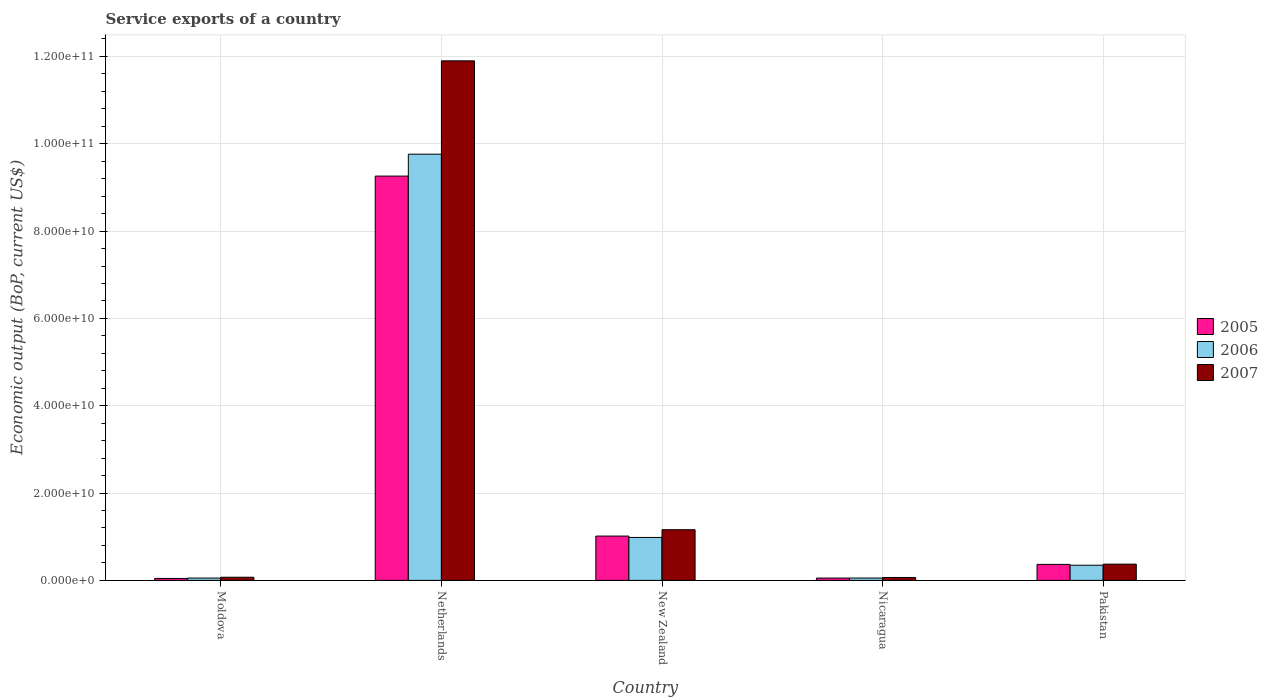How many groups of bars are there?
Offer a very short reply. 5. Are the number of bars per tick equal to the number of legend labels?
Offer a very short reply. Yes. How many bars are there on the 5th tick from the left?
Offer a terse response. 3. How many bars are there on the 2nd tick from the right?
Your answer should be very brief. 3. What is the label of the 1st group of bars from the left?
Make the answer very short. Moldova. What is the service exports in 2005 in Pakistan?
Your answer should be compact. 3.66e+09. Across all countries, what is the maximum service exports in 2006?
Your answer should be very brief. 9.76e+1. Across all countries, what is the minimum service exports in 2007?
Keep it short and to the point. 6.66e+08. In which country was the service exports in 2005 maximum?
Your answer should be very brief. Netherlands. In which country was the service exports in 2007 minimum?
Give a very brief answer. Nicaragua. What is the total service exports in 2007 in the graph?
Your answer should be very brief. 1.36e+11. What is the difference between the service exports in 2007 in Moldova and that in Netherlands?
Your answer should be compact. -1.18e+11. What is the difference between the service exports in 2006 in Nicaragua and the service exports in 2005 in Moldova?
Your answer should be very brief. 9.26e+07. What is the average service exports in 2006 per country?
Provide a short and direct response. 2.24e+1. What is the difference between the service exports of/in 2005 and service exports of/in 2006 in Pakistan?
Offer a very short reply. 1.89e+08. What is the ratio of the service exports in 2007 in Netherlands to that in Nicaragua?
Offer a terse response. 178.76. Is the service exports in 2006 in Netherlands less than that in New Zealand?
Give a very brief answer. No. Is the difference between the service exports in 2005 in New Zealand and Nicaragua greater than the difference between the service exports in 2006 in New Zealand and Nicaragua?
Your answer should be very brief. Yes. What is the difference between the highest and the second highest service exports in 2006?
Offer a very short reply. -6.36e+09. What is the difference between the highest and the lowest service exports in 2007?
Provide a succinct answer. 1.18e+11. Is it the case that in every country, the sum of the service exports in 2006 and service exports in 2005 is greater than the service exports in 2007?
Make the answer very short. Yes. How many countries are there in the graph?
Your response must be concise. 5. Are the values on the major ticks of Y-axis written in scientific E-notation?
Ensure brevity in your answer.  Yes. Does the graph contain any zero values?
Offer a terse response. No. Where does the legend appear in the graph?
Give a very brief answer. Center right. How many legend labels are there?
Your answer should be compact. 3. How are the legend labels stacked?
Give a very brief answer. Vertical. What is the title of the graph?
Your response must be concise. Service exports of a country. Does "1994" appear as one of the legend labels in the graph?
Make the answer very short. No. What is the label or title of the Y-axis?
Make the answer very short. Economic output (BoP, current US$). What is the Economic output (BoP, current US$) of 2005 in Moldova?
Give a very brief answer. 4.46e+08. What is the Economic output (BoP, current US$) of 2006 in Moldova?
Offer a terse response. 5.35e+08. What is the Economic output (BoP, current US$) of 2007 in Moldova?
Make the answer very short. 7.19e+08. What is the Economic output (BoP, current US$) of 2005 in Netherlands?
Give a very brief answer. 9.26e+1. What is the Economic output (BoP, current US$) in 2006 in Netherlands?
Offer a terse response. 9.76e+1. What is the Economic output (BoP, current US$) of 2007 in Netherlands?
Give a very brief answer. 1.19e+11. What is the Economic output (BoP, current US$) of 2005 in New Zealand?
Offer a very short reply. 1.02e+1. What is the Economic output (BoP, current US$) of 2006 in New Zealand?
Give a very brief answer. 9.84e+09. What is the Economic output (BoP, current US$) in 2007 in New Zealand?
Offer a terse response. 1.16e+1. What is the Economic output (BoP, current US$) of 2005 in Nicaragua?
Provide a short and direct response. 5.31e+08. What is the Economic output (BoP, current US$) in 2006 in Nicaragua?
Provide a short and direct response. 5.39e+08. What is the Economic output (BoP, current US$) of 2007 in Nicaragua?
Your response must be concise. 6.66e+08. What is the Economic output (BoP, current US$) of 2005 in Pakistan?
Offer a terse response. 3.66e+09. What is the Economic output (BoP, current US$) of 2006 in Pakistan?
Provide a succinct answer. 3.48e+09. What is the Economic output (BoP, current US$) in 2007 in Pakistan?
Your answer should be compact. 3.72e+09. Across all countries, what is the maximum Economic output (BoP, current US$) of 2005?
Your answer should be compact. 9.26e+1. Across all countries, what is the maximum Economic output (BoP, current US$) in 2006?
Offer a very short reply. 9.76e+1. Across all countries, what is the maximum Economic output (BoP, current US$) in 2007?
Ensure brevity in your answer.  1.19e+11. Across all countries, what is the minimum Economic output (BoP, current US$) of 2005?
Give a very brief answer. 4.46e+08. Across all countries, what is the minimum Economic output (BoP, current US$) in 2006?
Your response must be concise. 5.35e+08. Across all countries, what is the minimum Economic output (BoP, current US$) in 2007?
Your answer should be compact. 6.66e+08. What is the total Economic output (BoP, current US$) in 2005 in the graph?
Your answer should be compact. 1.07e+11. What is the total Economic output (BoP, current US$) in 2006 in the graph?
Ensure brevity in your answer.  1.12e+11. What is the total Economic output (BoP, current US$) in 2007 in the graph?
Keep it short and to the point. 1.36e+11. What is the difference between the Economic output (BoP, current US$) of 2005 in Moldova and that in Netherlands?
Make the answer very short. -9.21e+1. What is the difference between the Economic output (BoP, current US$) of 2006 in Moldova and that in Netherlands?
Offer a very short reply. -9.71e+1. What is the difference between the Economic output (BoP, current US$) of 2007 in Moldova and that in Netherlands?
Keep it short and to the point. -1.18e+11. What is the difference between the Economic output (BoP, current US$) of 2005 in Moldova and that in New Zealand?
Make the answer very short. -9.71e+09. What is the difference between the Economic output (BoP, current US$) in 2006 in Moldova and that in New Zealand?
Your answer should be very brief. -9.30e+09. What is the difference between the Economic output (BoP, current US$) in 2007 in Moldova and that in New Zealand?
Your answer should be very brief. -1.09e+1. What is the difference between the Economic output (BoP, current US$) of 2005 in Moldova and that in Nicaragua?
Your answer should be very brief. -8.46e+07. What is the difference between the Economic output (BoP, current US$) of 2006 in Moldova and that in Nicaragua?
Give a very brief answer. -3.60e+06. What is the difference between the Economic output (BoP, current US$) in 2007 in Moldova and that in Nicaragua?
Provide a short and direct response. 5.38e+07. What is the difference between the Economic output (BoP, current US$) in 2005 in Moldova and that in Pakistan?
Provide a short and direct response. -3.22e+09. What is the difference between the Economic output (BoP, current US$) in 2006 in Moldova and that in Pakistan?
Your response must be concise. -2.94e+09. What is the difference between the Economic output (BoP, current US$) of 2007 in Moldova and that in Pakistan?
Your answer should be compact. -3.00e+09. What is the difference between the Economic output (BoP, current US$) in 2005 in Netherlands and that in New Zealand?
Make the answer very short. 8.24e+1. What is the difference between the Economic output (BoP, current US$) of 2006 in Netherlands and that in New Zealand?
Provide a short and direct response. 8.78e+1. What is the difference between the Economic output (BoP, current US$) of 2007 in Netherlands and that in New Zealand?
Provide a succinct answer. 1.07e+11. What is the difference between the Economic output (BoP, current US$) of 2005 in Netherlands and that in Nicaragua?
Offer a terse response. 9.21e+1. What is the difference between the Economic output (BoP, current US$) in 2006 in Netherlands and that in Nicaragua?
Ensure brevity in your answer.  9.71e+1. What is the difference between the Economic output (BoP, current US$) of 2007 in Netherlands and that in Nicaragua?
Ensure brevity in your answer.  1.18e+11. What is the difference between the Economic output (BoP, current US$) of 2005 in Netherlands and that in Pakistan?
Your answer should be very brief. 8.89e+1. What is the difference between the Economic output (BoP, current US$) in 2006 in Netherlands and that in Pakistan?
Offer a very short reply. 9.41e+1. What is the difference between the Economic output (BoP, current US$) in 2007 in Netherlands and that in Pakistan?
Offer a very short reply. 1.15e+11. What is the difference between the Economic output (BoP, current US$) of 2005 in New Zealand and that in Nicaragua?
Your response must be concise. 9.62e+09. What is the difference between the Economic output (BoP, current US$) in 2006 in New Zealand and that in Nicaragua?
Ensure brevity in your answer.  9.30e+09. What is the difference between the Economic output (BoP, current US$) of 2007 in New Zealand and that in Nicaragua?
Your response must be concise. 1.09e+1. What is the difference between the Economic output (BoP, current US$) of 2005 in New Zealand and that in Pakistan?
Keep it short and to the point. 6.49e+09. What is the difference between the Economic output (BoP, current US$) in 2006 in New Zealand and that in Pakistan?
Provide a short and direct response. 6.36e+09. What is the difference between the Economic output (BoP, current US$) of 2007 in New Zealand and that in Pakistan?
Provide a succinct answer. 7.88e+09. What is the difference between the Economic output (BoP, current US$) of 2005 in Nicaragua and that in Pakistan?
Your answer should be very brief. -3.13e+09. What is the difference between the Economic output (BoP, current US$) of 2006 in Nicaragua and that in Pakistan?
Keep it short and to the point. -2.94e+09. What is the difference between the Economic output (BoP, current US$) in 2007 in Nicaragua and that in Pakistan?
Offer a terse response. -3.06e+09. What is the difference between the Economic output (BoP, current US$) of 2005 in Moldova and the Economic output (BoP, current US$) of 2006 in Netherlands?
Ensure brevity in your answer.  -9.72e+1. What is the difference between the Economic output (BoP, current US$) in 2005 in Moldova and the Economic output (BoP, current US$) in 2007 in Netherlands?
Offer a very short reply. -1.19e+11. What is the difference between the Economic output (BoP, current US$) of 2006 in Moldova and the Economic output (BoP, current US$) of 2007 in Netherlands?
Make the answer very short. -1.18e+11. What is the difference between the Economic output (BoP, current US$) in 2005 in Moldova and the Economic output (BoP, current US$) in 2006 in New Zealand?
Ensure brevity in your answer.  -9.39e+09. What is the difference between the Economic output (BoP, current US$) in 2005 in Moldova and the Economic output (BoP, current US$) in 2007 in New Zealand?
Your answer should be compact. -1.12e+1. What is the difference between the Economic output (BoP, current US$) in 2006 in Moldova and the Economic output (BoP, current US$) in 2007 in New Zealand?
Provide a succinct answer. -1.11e+1. What is the difference between the Economic output (BoP, current US$) in 2005 in Moldova and the Economic output (BoP, current US$) in 2006 in Nicaragua?
Make the answer very short. -9.26e+07. What is the difference between the Economic output (BoP, current US$) of 2005 in Moldova and the Economic output (BoP, current US$) of 2007 in Nicaragua?
Provide a succinct answer. -2.19e+08. What is the difference between the Economic output (BoP, current US$) in 2006 in Moldova and the Economic output (BoP, current US$) in 2007 in Nicaragua?
Your answer should be very brief. -1.30e+08. What is the difference between the Economic output (BoP, current US$) of 2005 in Moldova and the Economic output (BoP, current US$) of 2006 in Pakistan?
Ensure brevity in your answer.  -3.03e+09. What is the difference between the Economic output (BoP, current US$) in 2005 in Moldova and the Economic output (BoP, current US$) in 2007 in Pakistan?
Offer a very short reply. -3.27e+09. What is the difference between the Economic output (BoP, current US$) of 2006 in Moldova and the Economic output (BoP, current US$) of 2007 in Pakistan?
Your response must be concise. -3.19e+09. What is the difference between the Economic output (BoP, current US$) in 2005 in Netherlands and the Economic output (BoP, current US$) in 2006 in New Zealand?
Ensure brevity in your answer.  8.28e+1. What is the difference between the Economic output (BoP, current US$) of 2005 in Netherlands and the Economic output (BoP, current US$) of 2007 in New Zealand?
Offer a very short reply. 8.10e+1. What is the difference between the Economic output (BoP, current US$) of 2006 in Netherlands and the Economic output (BoP, current US$) of 2007 in New Zealand?
Give a very brief answer. 8.60e+1. What is the difference between the Economic output (BoP, current US$) of 2005 in Netherlands and the Economic output (BoP, current US$) of 2006 in Nicaragua?
Make the answer very short. 9.21e+1. What is the difference between the Economic output (BoP, current US$) in 2005 in Netherlands and the Economic output (BoP, current US$) in 2007 in Nicaragua?
Your response must be concise. 9.19e+1. What is the difference between the Economic output (BoP, current US$) in 2006 in Netherlands and the Economic output (BoP, current US$) in 2007 in Nicaragua?
Your answer should be compact. 9.69e+1. What is the difference between the Economic output (BoP, current US$) of 2005 in Netherlands and the Economic output (BoP, current US$) of 2006 in Pakistan?
Ensure brevity in your answer.  8.91e+1. What is the difference between the Economic output (BoP, current US$) in 2005 in Netherlands and the Economic output (BoP, current US$) in 2007 in Pakistan?
Give a very brief answer. 8.89e+1. What is the difference between the Economic output (BoP, current US$) in 2006 in Netherlands and the Economic output (BoP, current US$) in 2007 in Pakistan?
Offer a very short reply. 9.39e+1. What is the difference between the Economic output (BoP, current US$) of 2005 in New Zealand and the Economic output (BoP, current US$) of 2006 in Nicaragua?
Make the answer very short. 9.61e+09. What is the difference between the Economic output (BoP, current US$) of 2005 in New Zealand and the Economic output (BoP, current US$) of 2007 in Nicaragua?
Give a very brief answer. 9.49e+09. What is the difference between the Economic output (BoP, current US$) in 2006 in New Zealand and the Economic output (BoP, current US$) in 2007 in Nicaragua?
Offer a terse response. 9.17e+09. What is the difference between the Economic output (BoP, current US$) of 2005 in New Zealand and the Economic output (BoP, current US$) of 2006 in Pakistan?
Keep it short and to the point. 6.68e+09. What is the difference between the Economic output (BoP, current US$) of 2005 in New Zealand and the Economic output (BoP, current US$) of 2007 in Pakistan?
Your answer should be compact. 6.43e+09. What is the difference between the Economic output (BoP, current US$) in 2006 in New Zealand and the Economic output (BoP, current US$) in 2007 in Pakistan?
Keep it short and to the point. 6.12e+09. What is the difference between the Economic output (BoP, current US$) in 2005 in Nicaragua and the Economic output (BoP, current US$) in 2006 in Pakistan?
Give a very brief answer. -2.95e+09. What is the difference between the Economic output (BoP, current US$) of 2005 in Nicaragua and the Economic output (BoP, current US$) of 2007 in Pakistan?
Offer a terse response. -3.19e+09. What is the difference between the Economic output (BoP, current US$) in 2006 in Nicaragua and the Economic output (BoP, current US$) in 2007 in Pakistan?
Your response must be concise. -3.18e+09. What is the average Economic output (BoP, current US$) in 2005 per country?
Your answer should be compact. 2.15e+1. What is the average Economic output (BoP, current US$) of 2006 per country?
Your response must be concise. 2.24e+1. What is the average Economic output (BoP, current US$) in 2007 per country?
Provide a short and direct response. 2.71e+1. What is the difference between the Economic output (BoP, current US$) in 2005 and Economic output (BoP, current US$) in 2006 in Moldova?
Your answer should be very brief. -8.90e+07. What is the difference between the Economic output (BoP, current US$) in 2005 and Economic output (BoP, current US$) in 2007 in Moldova?
Provide a short and direct response. -2.73e+08. What is the difference between the Economic output (BoP, current US$) in 2006 and Economic output (BoP, current US$) in 2007 in Moldova?
Ensure brevity in your answer.  -1.84e+08. What is the difference between the Economic output (BoP, current US$) in 2005 and Economic output (BoP, current US$) in 2006 in Netherlands?
Your answer should be compact. -5.02e+09. What is the difference between the Economic output (BoP, current US$) of 2005 and Economic output (BoP, current US$) of 2007 in Netherlands?
Provide a short and direct response. -2.64e+1. What is the difference between the Economic output (BoP, current US$) in 2006 and Economic output (BoP, current US$) in 2007 in Netherlands?
Ensure brevity in your answer.  -2.14e+1. What is the difference between the Economic output (BoP, current US$) of 2005 and Economic output (BoP, current US$) of 2006 in New Zealand?
Your response must be concise. 3.15e+08. What is the difference between the Economic output (BoP, current US$) in 2005 and Economic output (BoP, current US$) in 2007 in New Zealand?
Make the answer very short. -1.45e+09. What is the difference between the Economic output (BoP, current US$) in 2006 and Economic output (BoP, current US$) in 2007 in New Zealand?
Ensure brevity in your answer.  -1.77e+09. What is the difference between the Economic output (BoP, current US$) in 2005 and Economic output (BoP, current US$) in 2006 in Nicaragua?
Offer a terse response. -8.00e+06. What is the difference between the Economic output (BoP, current US$) of 2005 and Economic output (BoP, current US$) of 2007 in Nicaragua?
Ensure brevity in your answer.  -1.35e+08. What is the difference between the Economic output (BoP, current US$) in 2006 and Economic output (BoP, current US$) in 2007 in Nicaragua?
Ensure brevity in your answer.  -1.27e+08. What is the difference between the Economic output (BoP, current US$) of 2005 and Economic output (BoP, current US$) of 2006 in Pakistan?
Ensure brevity in your answer.  1.89e+08. What is the difference between the Economic output (BoP, current US$) in 2005 and Economic output (BoP, current US$) in 2007 in Pakistan?
Provide a succinct answer. -5.57e+07. What is the difference between the Economic output (BoP, current US$) of 2006 and Economic output (BoP, current US$) of 2007 in Pakistan?
Your response must be concise. -2.45e+08. What is the ratio of the Economic output (BoP, current US$) of 2005 in Moldova to that in Netherlands?
Make the answer very short. 0. What is the ratio of the Economic output (BoP, current US$) in 2006 in Moldova to that in Netherlands?
Offer a terse response. 0.01. What is the ratio of the Economic output (BoP, current US$) of 2007 in Moldova to that in Netherlands?
Ensure brevity in your answer.  0.01. What is the ratio of the Economic output (BoP, current US$) in 2005 in Moldova to that in New Zealand?
Ensure brevity in your answer.  0.04. What is the ratio of the Economic output (BoP, current US$) in 2006 in Moldova to that in New Zealand?
Your answer should be very brief. 0.05. What is the ratio of the Economic output (BoP, current US$) in 2007 in Moldova to that in New Zealand?
Your response must be concise. 0.06. What is the ratio of the Economic output (BoP, current US$) in 2005 in Moldova to that in Nicaragua?
Your response must be concise. 0.84. What is the ratio of the Economic output (BoP, current US$) of 2007 in Moldova to that in Nicaragua?
Provide a short and direct response. 1.08. What is the ratio of the Economic output (BoP, current US$) of 2005 in Moldova to that in Pakistan?
Provide a short and direct response. 0.12. What is the ratio of the Economic output (BoP, current US$) in 2006 in Moldova to that in Pakistan?
Your response must be concise. 0.15. What is the ratio of the Economic output (BoP, current US$) of 2007 in Moldova to that in Pakistan?
Make the answer very short. 0.19. What is the ratio of the Economic output (BoP, current US$) of 2005 in Netherlands to that in New Zealand?
Provide a succinct answer. 9.12. What is the ratio of the Economic output (BoP, current US$) in 2006 in Netherlands to that in New Zealand?
Your answer should be compact. 9.92. What is the ratio of the Economic output (BoP, current US$) in 2007 in Netherlands to that in New Zealand?
Keep it short and to the point. 10.25. What is the ratio of the Economic output (BoP, current US$) in 2005 in Netherlands to that in Nicaragua?
Keep it short and to the point. 174.48. What is the ratio of the Economic output (BoP, current US$) of 2006 in Netherlands to that in Nicaragua?
Provide a short and direct response. 181.2. What is the ratio of the Economic output (BoP, current US$) of 2007 in Netherlands to that in Nicaragua?
Your answer should be compact. 178.76. What is the ratio of the Economic output (BoP, current US$) of 2005 in Netherlands to that in Pakistan?
Provide a succinct answer. 25.26. What is the ratio of the Economic output (BoP, current US$) of 2006 in Netherlands to that in Pakistan?
Make the answer very short. 28.08. What is the ratio of the Economic output (BoP, current US$) in 2007 in Netherlands to that in Pakistan?
Make the answer very short. 31.98. What is the ratio of the Economic output (BoP, current US$) of 2005 in New Zealand to that in Nicaragua?
Ensure brevity in your answer.  19.13. What is the ratio of the Economic output (BoP, current US$) in 2006 in New Zealand to that in Nicaragua?
Your answer should be compact. 18.26. What is the ratio of the Economic output (BoP, current US$) in 2007 in New Zealand to that in Nicaragua?
Provide a succinct answer. 17.43. What is the ratio of the Economic output (BoP, current US$) of 2005 in New Zealand to that in Pakistan?
Your response must be concise. 2.77. What is the ratio of the Economic output (BoP, current US$) in 2006 in New Zealand to that in Pakistan?
Provide a short and direct response. 2.83. What is the ratio of the Economic output (BoP, current US$) in 2007 in New Zealand to that in Pakistan?
Ensure brevity in your answer.  3.12. What is the ratio of the Economic output (BoP, current US$) in 2005 in Nicaragua to that in Pakistan?
Give a very brief answer. 0.14. What is the ratio of the Economic output (BoP, current US$) in 2006 in Nicaragua to that in Pakistan?
Give a very brief answer. 0.15. What is the ratio of the Economic output (BoP, current US$) of 2007 in Nicaragua to that in Pakistan?
Offer a very short reply. 0.18. What is the difference between the highest and the second highest Economic output (BoP, current US$) of 2005?
Your answer should be compact. 8.24e+1. What is the difference between the highest and the second highest Economic output (BoP, current US$) of 2006?
Provide a short and direct response. 8.78e+1. What is the difference between the highest and the second highest Economic output (BoP, current US$) in 2007?
Provide a short and direct response. 1.07e+11. What is the difference between the highest and the lowest Economic output (BoP, current US$) of 2005?
Your answer should be very brief. 9.21e+1. What is the difference between the highest and the lowest Economic output (BoP, current US$) in 2006?
Offer a very short reply. 9.71e+1. What is the difference between the highest and the lowest Economic output (BoP, current US$) of 2007?
Offer a very short reply. 1.18e+11. 